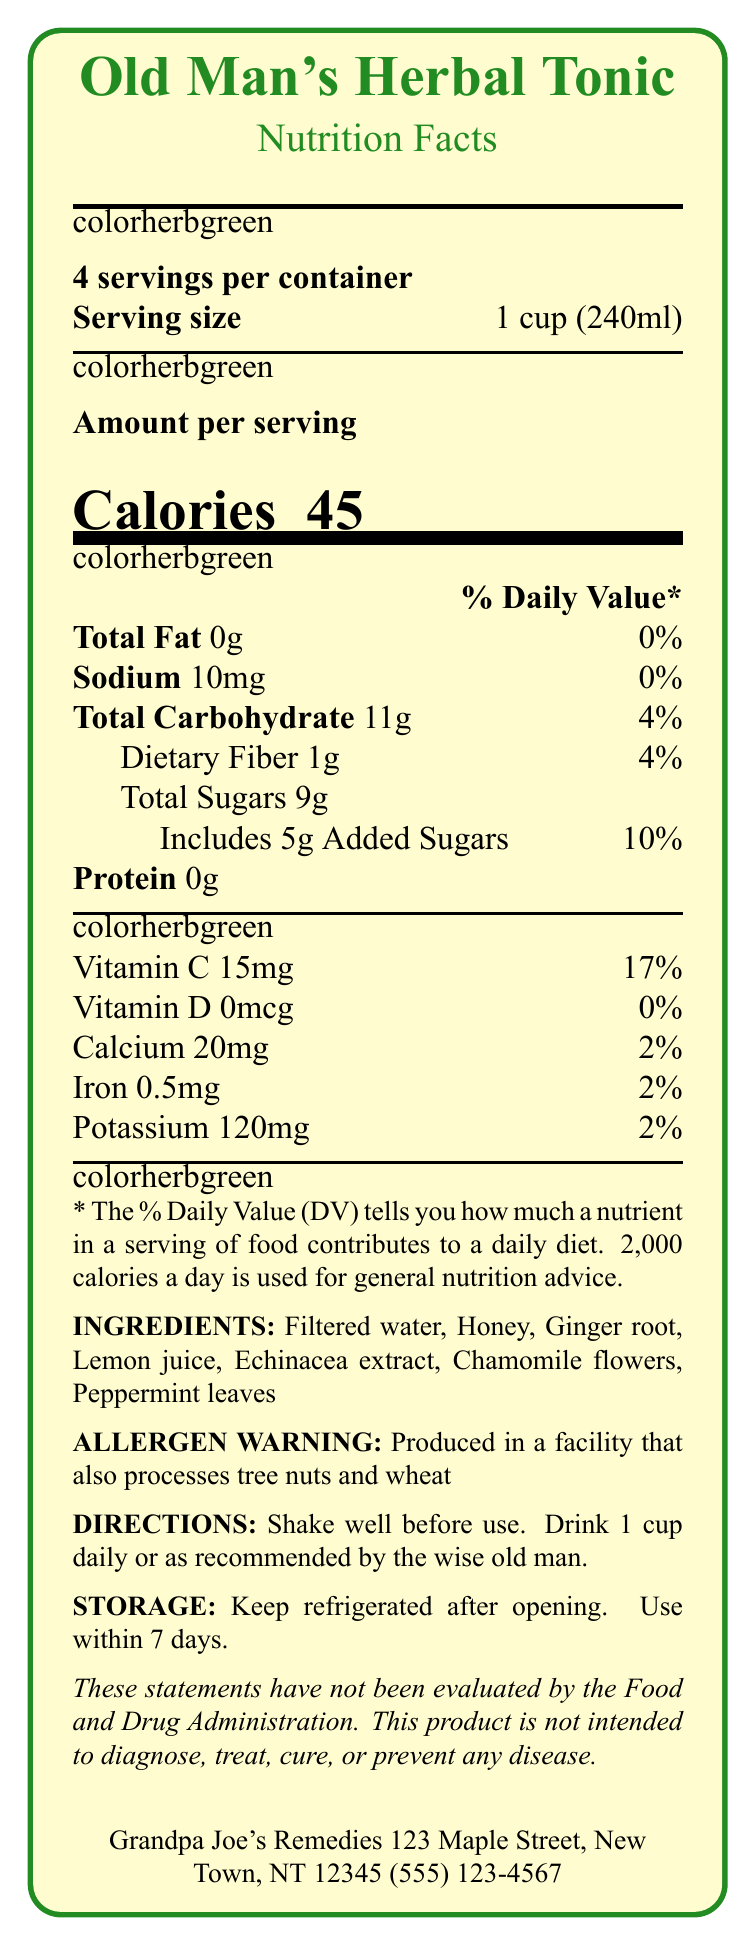who manufactures Old Man's Herbal Tonic? The document states that the manufacturer is Grandpa Joe's Remedies, located at 123 Maple Street, New Town, NT 12345.
Answer: Grandpa Joe's Remedies what is the serving size of Old Man's Herbal Tonic? The serving size is explicitly mentioned in the document as 1 cup (240ml).
Answer: 1 cup (240ml) how many servings are there in one container? The document states that there are 4 servings per container.
Answer: 4 servings how many calories are there per serving? The calories per serving are clearly listed as 45.
Answer: 45 calories what is the daily value percentage of calcium per serving? The document specifies that the daily value percentage of calcium per serving is 2%.
Answer: 2% which ingredients are included in Old Man's Herbal Tonic? The document lists all these ingredients.
Answer: Filtered water, Honey, Ginger root, Lemon juice, Echinacea extract, Chamomile flowers, Peppermint leaves how much total fat is in one serving? The amount of total fat per serving is listed as 0g.
Answer: 0g how should the tonic be stored after opening? The storage instructions are clearly stated in the document.
Answer: Keep refrigerated after opening. Use within 7 days. what is the daily value percentage of vitamin C per serving? The document specifies that the daily value percentage of vitamin C per serving is 17%.
Answer: 17% what is the allergen warning associated with this product? The allergen warning is explicitly mentioned in the document.
Answer: Produced in a facility that also processes tree nuts and wheat what directions are given for consuming the tonic? The consumption directions are plainly stated in the document.
Answer: Shake well before use. Drink 1 cup daily or as recommended by the wise old man. how much added sugars are there per serving? The document mentions that there are 5g of added sugars per serving.
Answer: 5g what is the amount of dietary fiber per serving and its daily value percentage? The document specifies that there is 1g of dietary fiber per serving, which is 4% of the daily value.
Answer: 1g, 4% who produced Old Man's Herbal Tonic? A. Grandpa Joe's Remedies B. Grandma Jane's Elixirs C. Uncle Tom's Tonics The document states that the tonic is produced by Grandpa Joe's Remedies.
Answer: A what is the daily value percentage of total carbohydrate per serving? A. 2% B. 4% C. 6% D. 10% The document specifies that the daily value percentage of total carbohydrate per serving is 4%.
Answer: B is there any protein in Old Man's Herbal Tonic? The document mentions that there is 0g of protein per serving.
Answer: No what is the primary purpose of this document? The main idea of the document is to convey the nutritional facts, ingredients, storage, and consumption directions for Old Man's Herbal Tonic.
Answer: To provide nutritional information and details about Old Man's Herbal Tonic how many calories does an entire container have? Since there are 4 servings per container and each serving has 45 calories, the total number of calories in the container is 45 * 4 = 180 calories.
Answer: 180 calories what are the benefits of the herbal ingredients in the tonic? The document does not provide detailed information on the benefits of each herbal ingredient.
Answer: Cannot be determined 